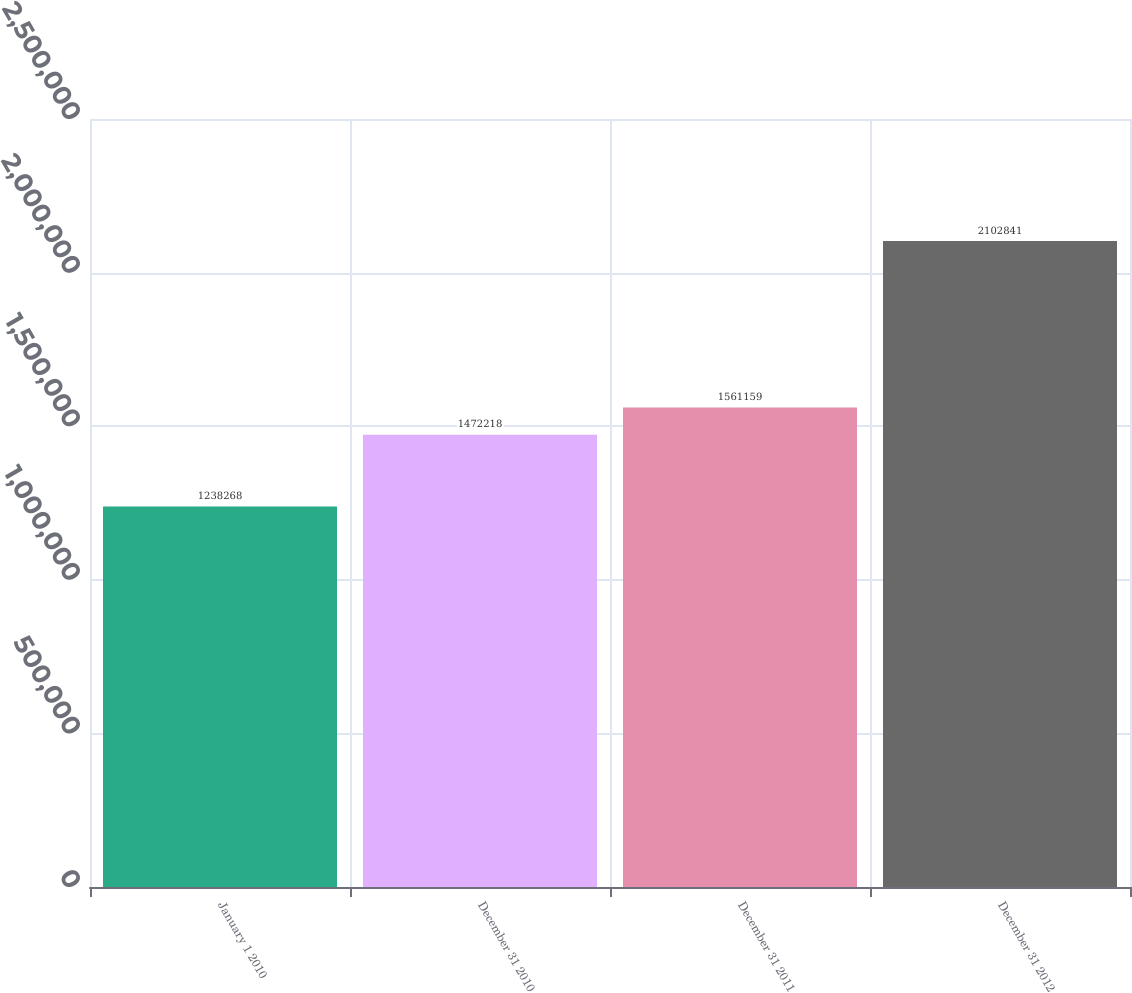<chart> <loc_0><loc_0><loc_500><loc_500><bar_chart><fcel>January 1 2010<fcel>December 31 2010<fcel>December 31 2011<fcel>December 31 2012<nl><fcel>1.23827e+06<fcel>1.47222e+06<fcel>1.56116e+06<fcel>2.10284e+06<nl></chart> 